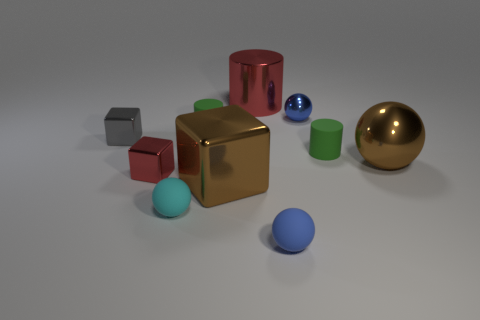What is the color of the big shiny ball?
Give a very brief answer. Brown. What is the size of the brown ball that is the same material as the large red thing?
Your answer should be very brief. Large. How many small gray objects are the same shape as the small red object?
Give a very brief answer. 1. Are there any other things that are the same size as the cyan sphere?
Offer a very short reply. Yes. There is a cylinder that is in front of the block to the left of the red metal block; how big is it?
Offer a terse response. Small. What material is the block that is the same size as the gray object?
Offer a terse response. Metal. Is there a green cylinder that has the same material as the big red cylinder?
Offer a very short reply. No. The metal thing left of the small metal block that is to the right of the small metal cube that is behind the red metal cube is what color?
Ensure brevity in your answer.  Gray. There is a small shiny object to the right of the red metallic cylinder; is its color the same as the matte sphere that is right of the large brown block?
Offer a very short reply. Yes. Is there anything else that has the same color as the large block?
Ensure brevity in your answer.  Yes. 